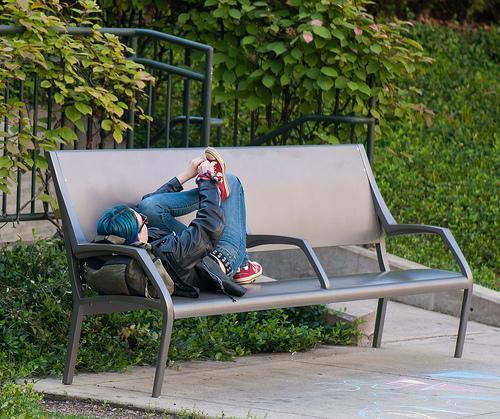How many benches in the park?
Give a very brief answer. 1. How many people on the bench?
Give a very brief answer. 1. How many people are using on the bench?
Give a very brief answer. 1. 